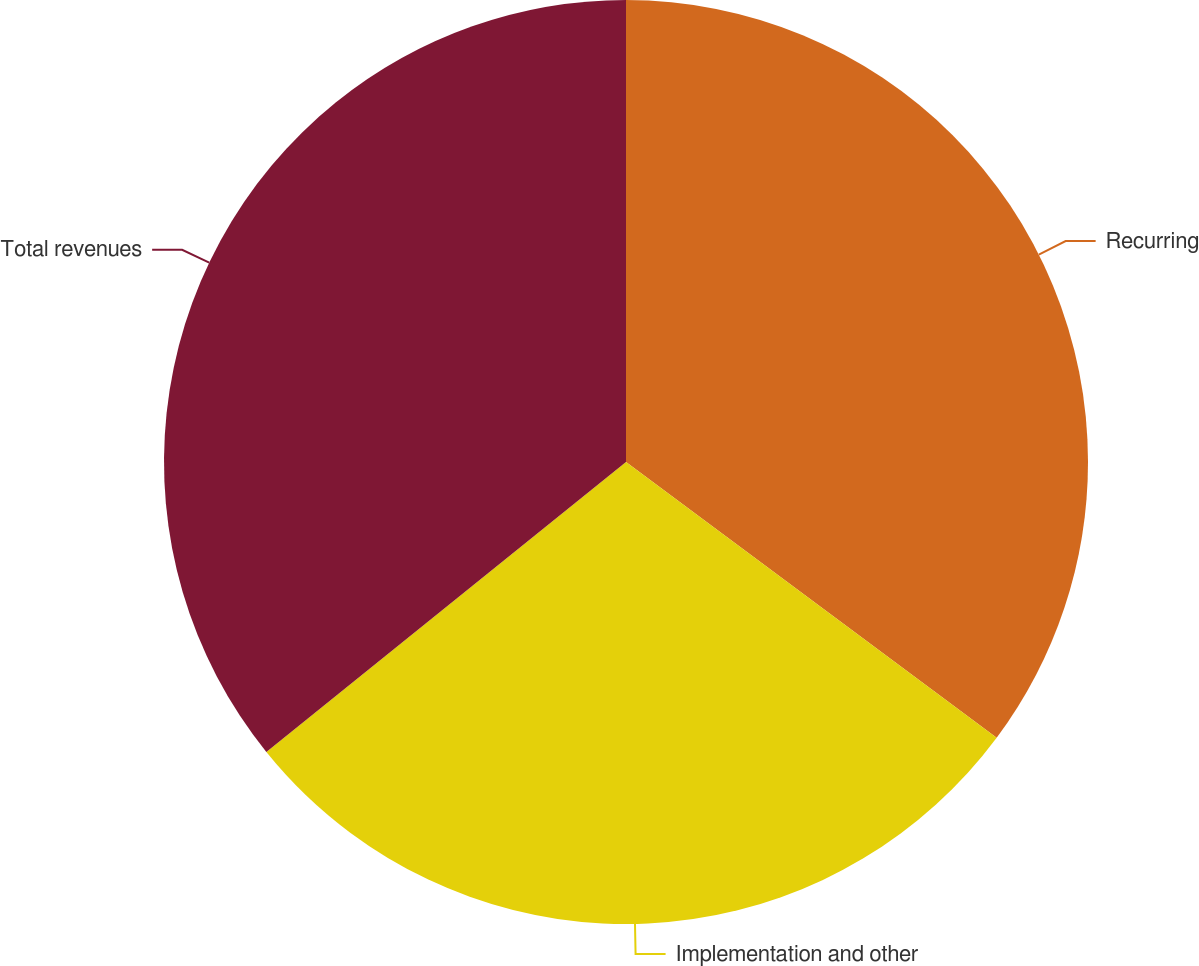<chart> <loc_0><loc_0><loc_500><loc_500><pie_chart><fcel>Recurring<fcel>Implementation and other<fcel>Total revenues<nl><fcel>35.18%<fcel>29.02%<fcel>35.8%<nl></chart> 